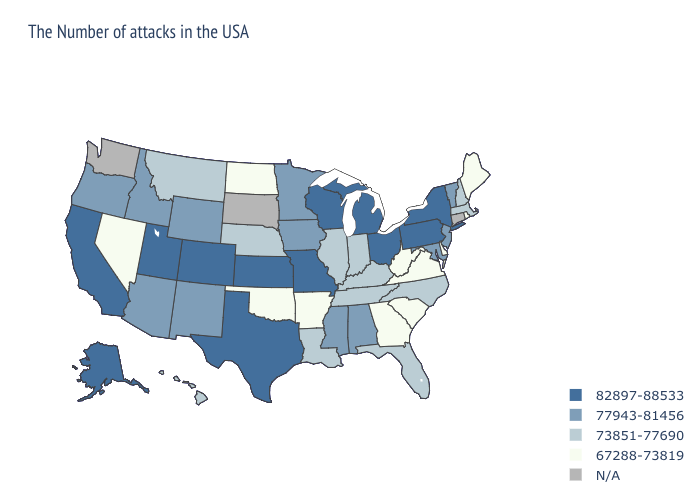Does New Jersey have the lowest value in the Northeast?
Be succinct. No. Does New Mexico have the lowest value in the West?
Write a very short answer. No. Name the states that have a value in the range 73851-77690?
Keep it brief. Massachusetts, New Hampshire, North Carolina, Florida, Kentucky, Indiana, Tennessee, Illinois, Louisiana, Nebraska, Montana, Hawaii. Does Nevada have the lowest value in the West?
Be succinct. Yes. What is the lowest value in states that border New Jersey?
Quick response, please. 67288-73819. What is the value of Louisiana?
Quick response, please. 73851-77690. What is the value of Vermont?
Give a very brief answer. 77943-81456. Name the states that have a value in the range N/A?
Write a very short answer. Connecticut, South Dakota, Washington. Name the states that have a value in the range 73851-77690?
Write a very short answer. Massachusetts, New Hampshire, North Carolina, Florida, Kentucky, Indiana, Tennessee, Illinois, Louisiana, Nebraska, Montana, Hawaii. What is the value of Louisiana?
Write a very short answer. 73851-77690. How many symbols are there in the legend?
Quick response, please. 5. Is the legend a continuous bar?
Be succinct. No. 